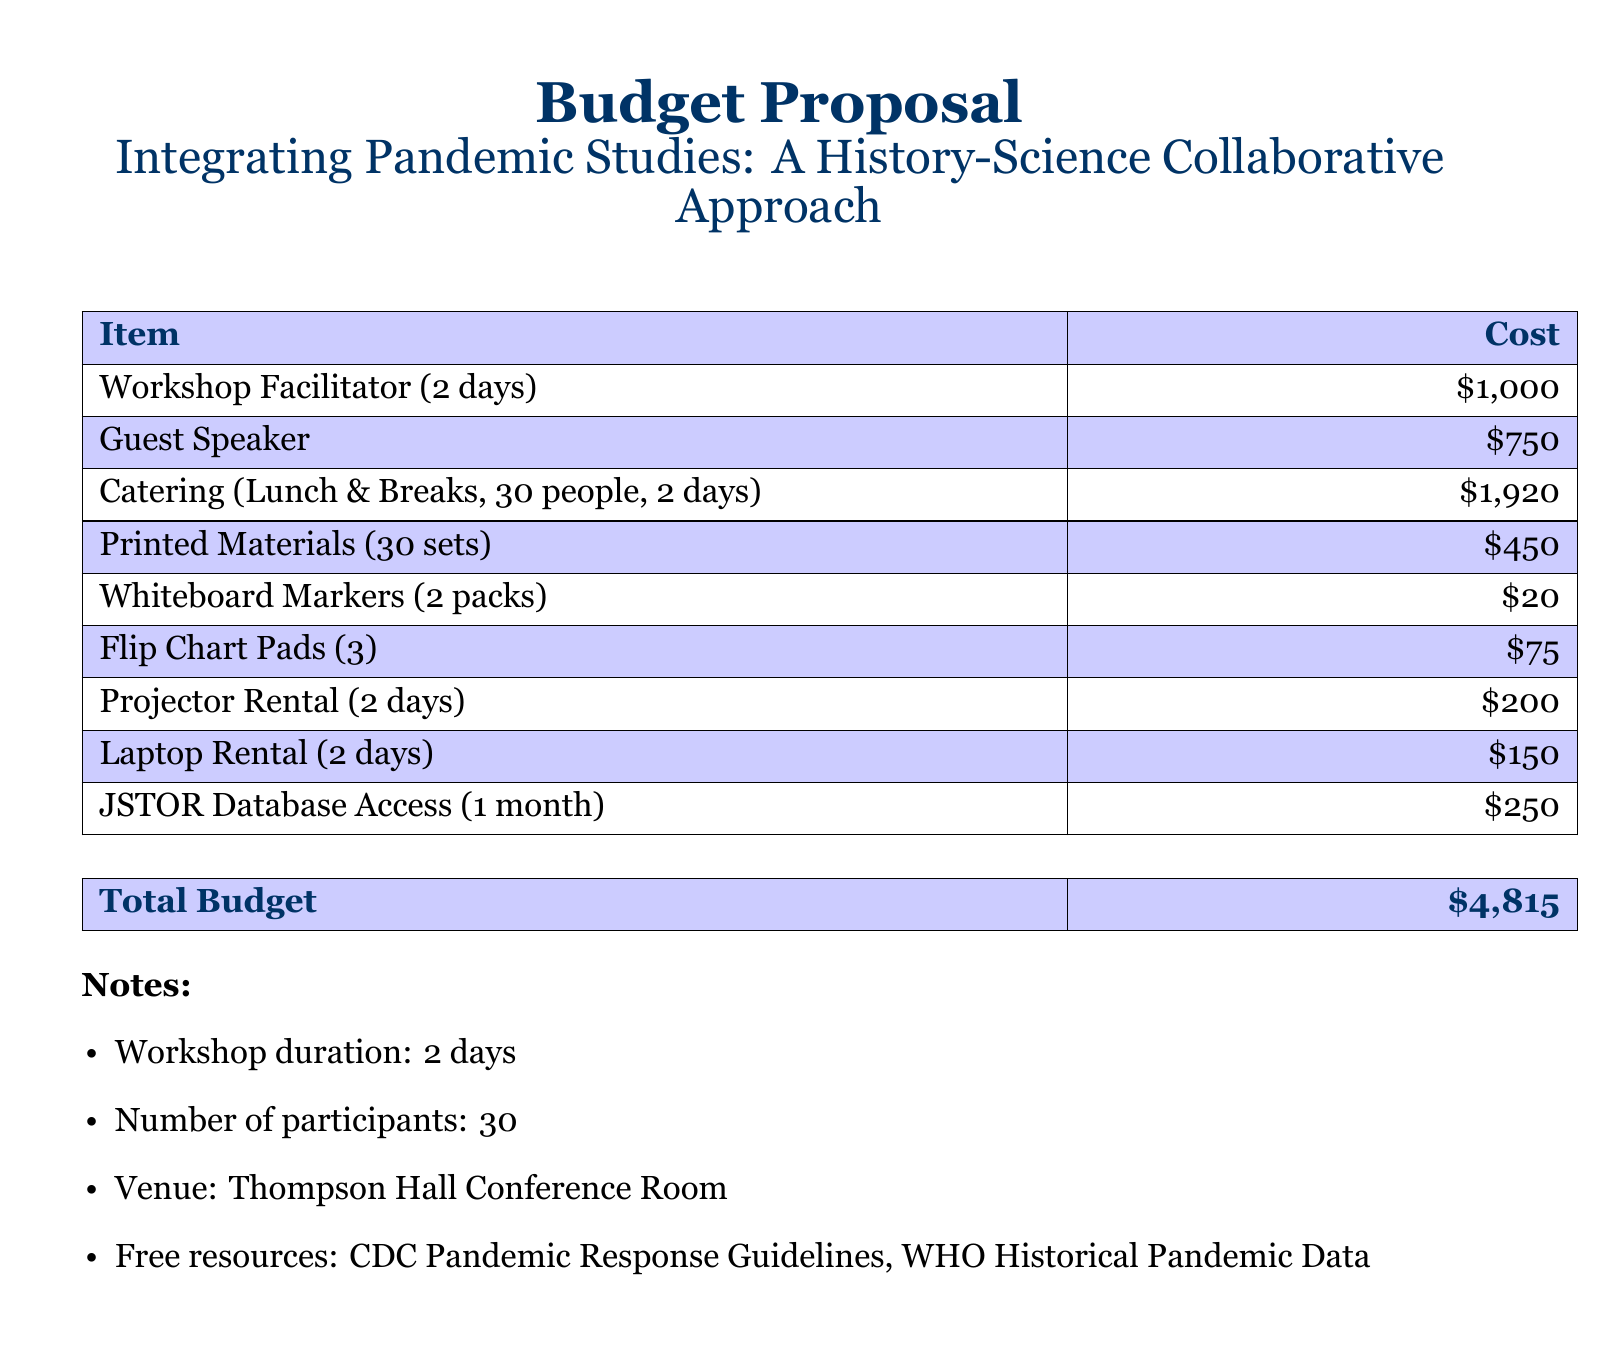What is the total budget? The total budget is stated in a dedicated section and summarizes all costs presented in the document.
Answer: $4,815 How many participants are expected? The number of participants is listed in the notes section of the document.
Answer: 30 What is the cost of catering? The catering cost is specified under the item list in the budget proposal.
Answer: $1,920 How much will the workshop facilitator be paid? The payment for the workshop facilitator for two days is clearly indicated in the budget.
Answer: $1,000 What venue will the workshop take place in? The venue information is provided in the notes section of the document.
Answer: Thompson Hall Conference Room How many days will the workshop last? The duration of the workshop is explicitly mentioned in the notes section.
Answer: 2 days What is the cost of printed materials? The cost allocated for printed materials is listed in the itemization of the budget.
Answer: $450 What is the cost of the guest speaker? The budget document specifies the cost associated with inviting a guest speaker for the workshop.
Answer: $750 How many whiteboard marker packs are needed? The number of packs needed is detailed in the itemized costs provided.
Answer: 2 packs 